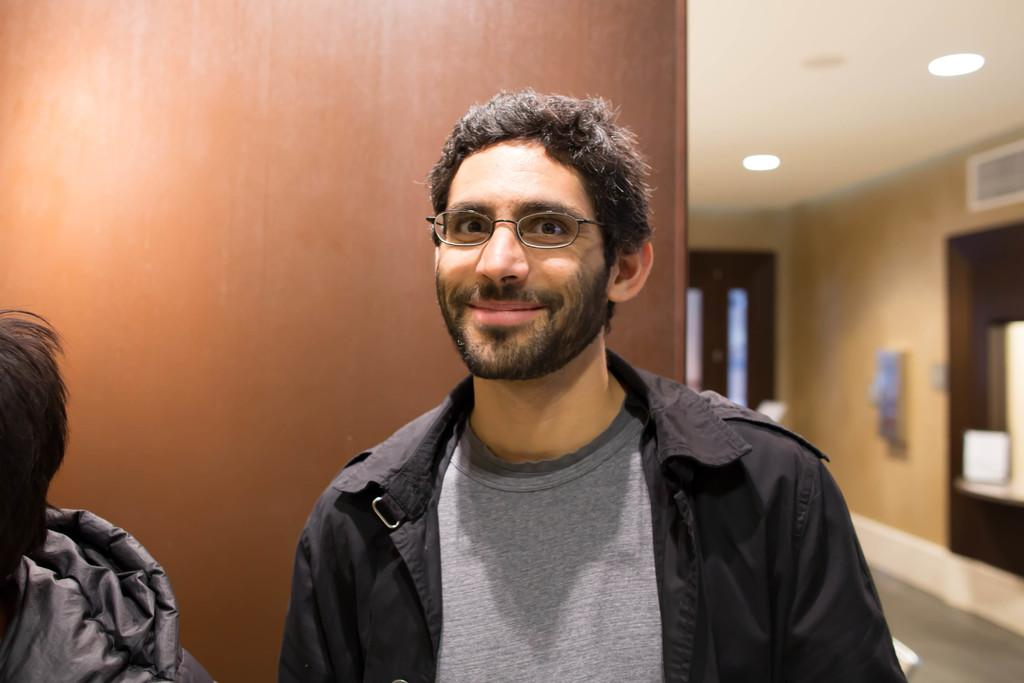What type of people are present in the image? There are men standing in the image. What can be seen on the ceiling in the image? There are lights on the ceiling in the image. What type of trousers are the men wearing in the image? The provided facts do not mention the type of trousers the men are wearing, so we cannot answer this question definitively. --- Facts: 1. There is a car in the image. 2. The car is parked on the street. 3. There are trees on the side of the street. 4. The sky is visible in the image. Absurd Topics: parrot, sand, dance Conversation: What is the main subject of the image? The main subject of the image is a car. Where is the car located in the image? The car is parked on the street in the image. What can be seen on the side of the street? There are trees on the side of the street in the image. What is visible in the background of the image? The sky is visible in the image. Reasoning: Let's think step by step in order to produce the conversation. We start by identifying the main subject in the image, which is the car. Then, we expand the conversation to include other details about the image, such as the car's location, the trees on the side of the street, and the sky in the background. Each question is designed to elicit a specific detail about the image that is known from the provided facts. Absurd Question/Answer: Can you tell me what color the parrot is in the image? There is no parrot present in the image, so we cannot answer this question definitively. 